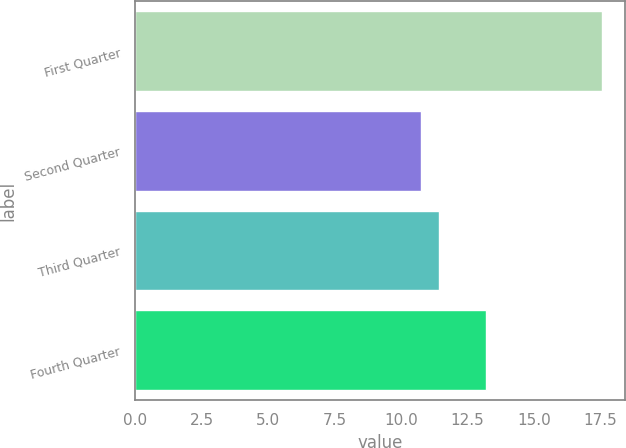Convert chart to OTSL. <chart><loc_0><loc_0><loc_500><loc_500><bar_chart><fcel>First Quarter<fcel>Second Quarter<fcel>Third Quarter<fcel>Fourth Quarter<nl><fcel>17.54<fcel>10.75<fcel>11.43<fcel>13.21<nl></chart> 